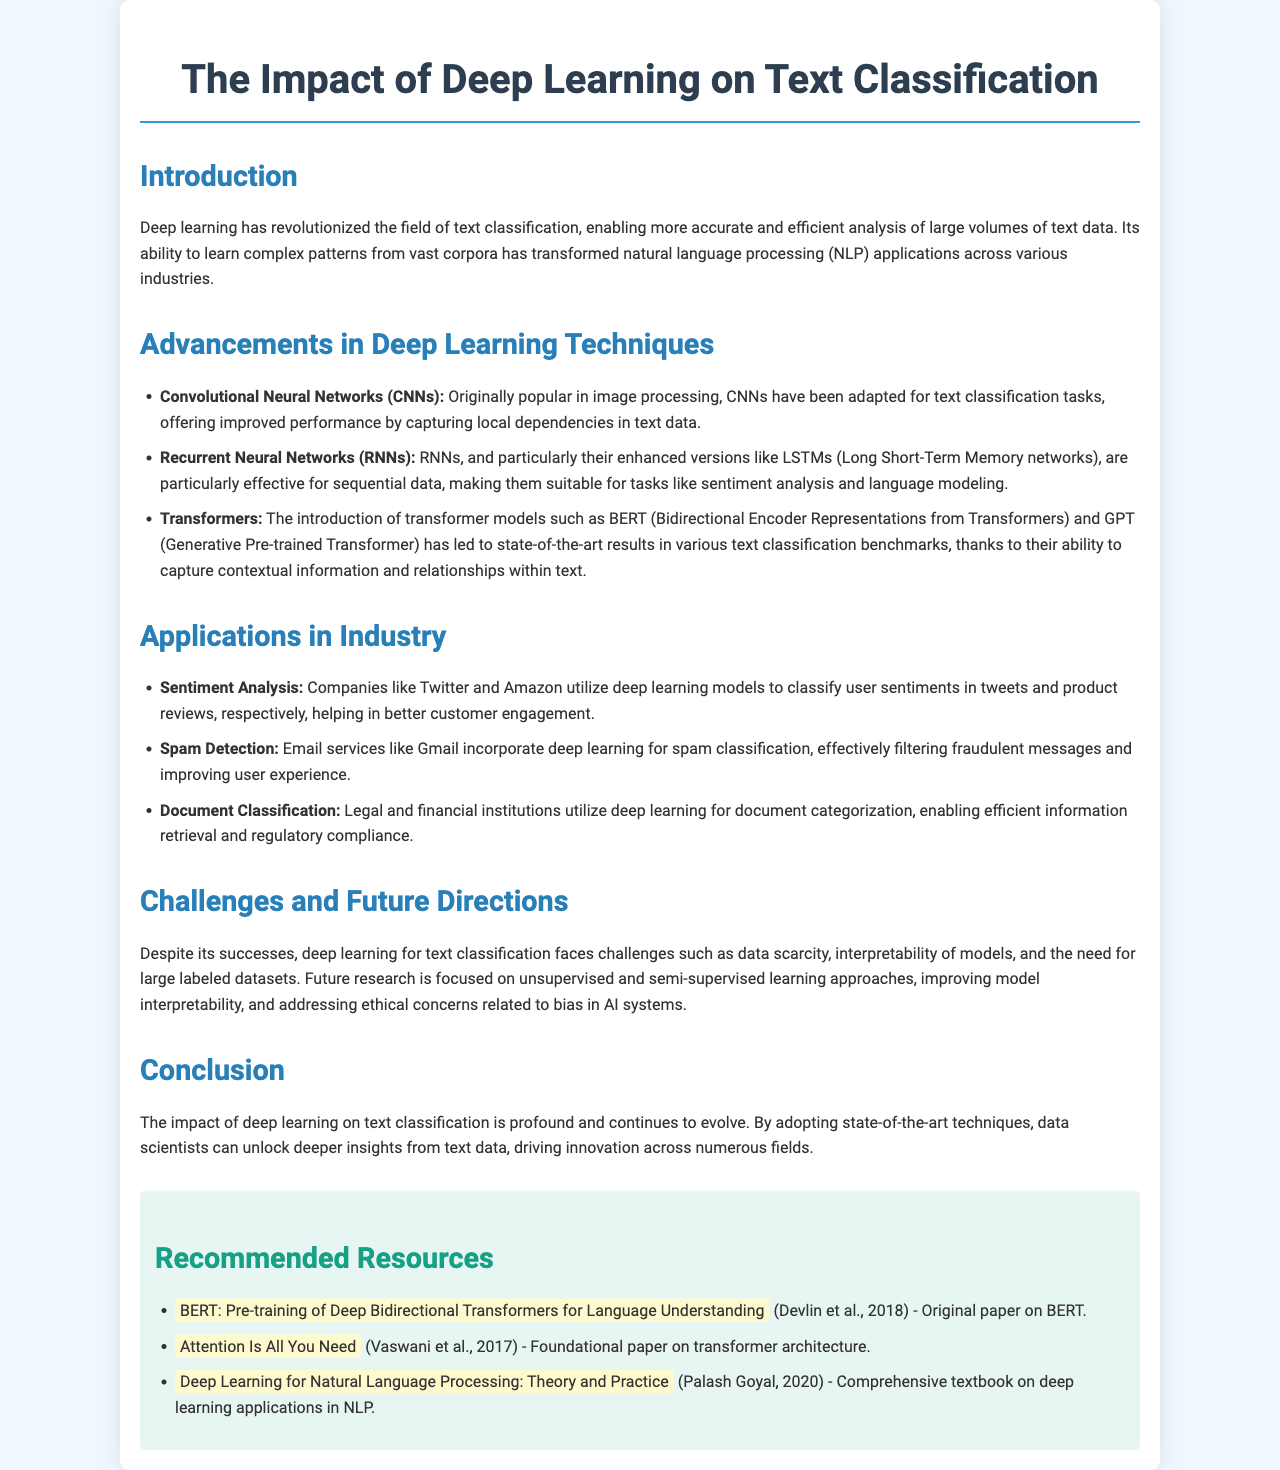What is the title of the brochure? The title is stated at the top of the document, indicating the main subject.
Answer: The Impact of Deep Learning on Text Classification Which deep learning technique is known for capturing local dependencies in text data? This is mentioned under the advancements section, specifically related to a type of neural network.
Answer: Convolutional Neural Networks (CNNs) What is the application of deep learning used by companies like Twitter and Amazon? This application is detailed in the industry applications section, specifically linked to user feedback.
Answer: Sentiment Analysis What year was the foundational paper on transformer architecture published? The publication year is mentioned alongside the title of the recommended resource in the document.
Answer: 2017 What are future research focuses in deep learning for text classification? Future directions are summarized towards the end of the document, highlighting challenges and research areas.
Answer: Unsupervised and semi-supervised learning approaches Which model is highlighted for its understanding of language through bidirectionality? This is mentioned under advancements in deep learning techniques, referring to a specific model.
Answer: BERT Who are the authors of the paper on BERT? The authors' names are stated in the recommended resources section of the document.
Answer: Devlin et al What color background is used for the resources section? The color is described in the styling details of the resources section, defining its visual appearance.
Answer: Light blue 